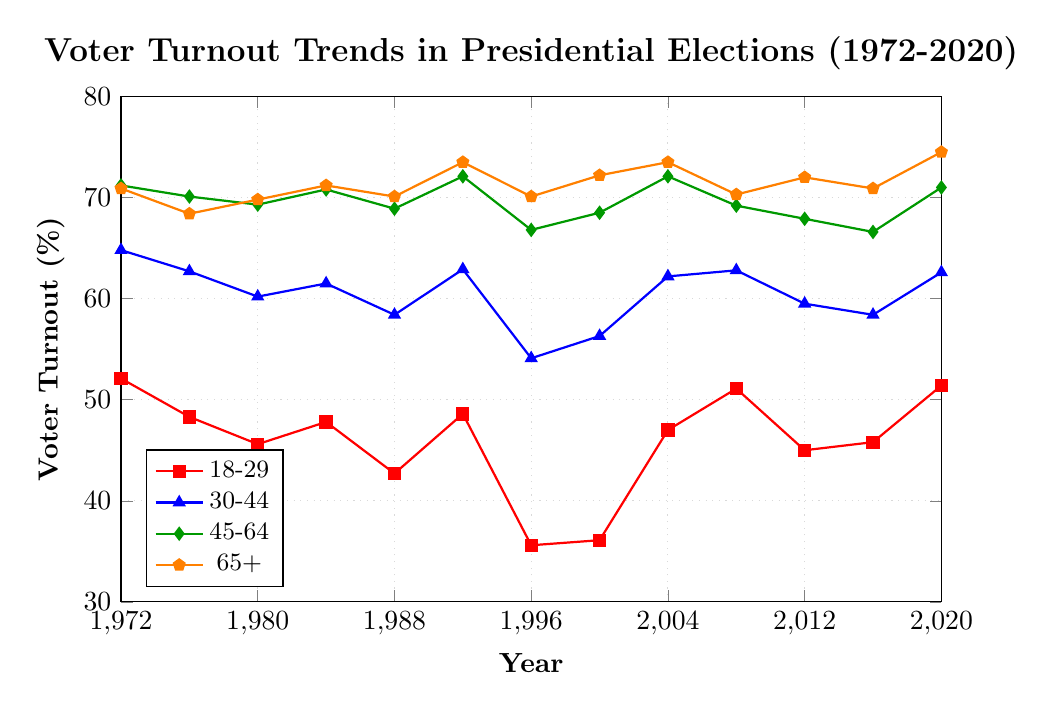What is the voter turnout trend for the 18-29 age group from 1972 to 2020? The voter turnout for the 18-29 age group starts at 52.1% in 1972, decreases to a low point of 35.6% in 1996, and then eventually rises back up to 51.4% in 2020.
Answer: It decreases and then increases Which age group had the highest voter turnout in 2020? By looking at the values in 2020, the 65+ age group has the highest voter turnout at 74.5%.
Answer: 65+ What is the average voter turnout for the 30-44 age group over the 50 years? Sum of turnout percentages: 64.8 + 62.7 + 60.2 + 61.5 + 58.4 + 62.9 + 54.1 + 56.3 + 62.2 + 62.8 + 59.5 + 58.4 + 62.6 = 796.4. There are 13 data points. Average = 796.4 / 13 ≈ 61.26%.
Answer: 61.26% Between 1996 and 2000, which age group showed the largest increase in voter turnout? Comparing the increases: 18-29 (36.1-35.6 = 0.5), 30-44 (56.3-54.1 = 2.2), 45-64 (68.5-66.8 = 1.7), 65+ (72.2-70.1 = 2.1). The 30-44 group has the largest increase (2.2%).
Answer: 30-44 What is the difference in voter turnout between the 45-64 and 65+ age groups in 2000? Voter turnout for 45-64 in 2000 is 68.5%, for 65+ is 72.2%. The difference is 72.2 - 68.5 = 3.7%.
Answer: 3.7% Which age group had the least variability in voter turnout over the 50 years? To determine variability, we look at the range (highest value - lowest value) for each group:
18-29: 52.1 - 35.6 = 16.5,
30-44: 64.8 - 54.1 = 10.7,
45-64: 72.1 - 66.6 = 5.5,
65+: 74.5 - 68.4 = 6.1. 
The 45-64 age group has the least variability with a range of 5.5%.
Answer: 45-64 Did the voter turnout for the 65+ age group increase or decrease from 1988 to 1992? In 1988, the voter turnout for 65+ was 70.1%, and in 1992 it was 73.5%, indicating an increase.
Answer: Increase Which age group had the largest decrease in voter turnout from 2008 to 2012? Comparing decreases: 18-29 (45.0 - 51.1 = -6.1), 30-44 (59.5 - 62.8 = -3.3), 45-64 (67.9 - 69.2 = -1.3), 65+ (72.0 - 70.3 = 1.7). The largest decrease is in the 18-29 group at -6.1%.
Answer: 18-29 